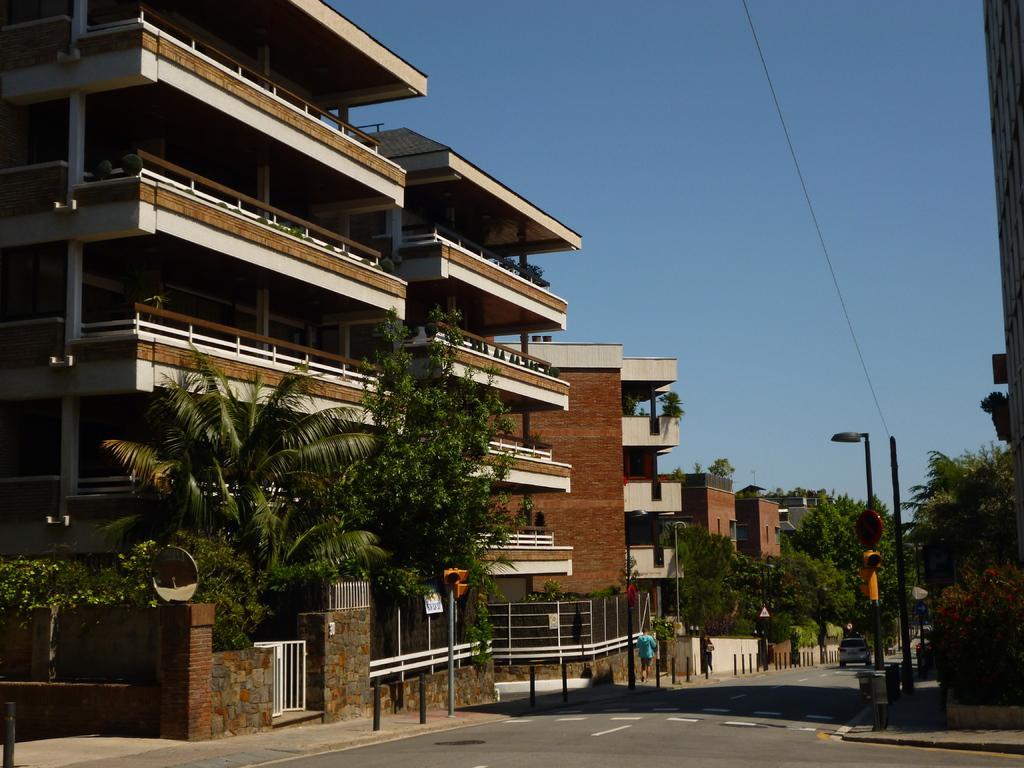In one or two sentences, can you explain what this image depicts? This is an outside view. At the bottom there is a road. On the road there is a car and I can see few people are walking on the footpath. On the right side there are some plants and poles. In the background there are many buildings and trees. At the top of the image I can see the sky. 